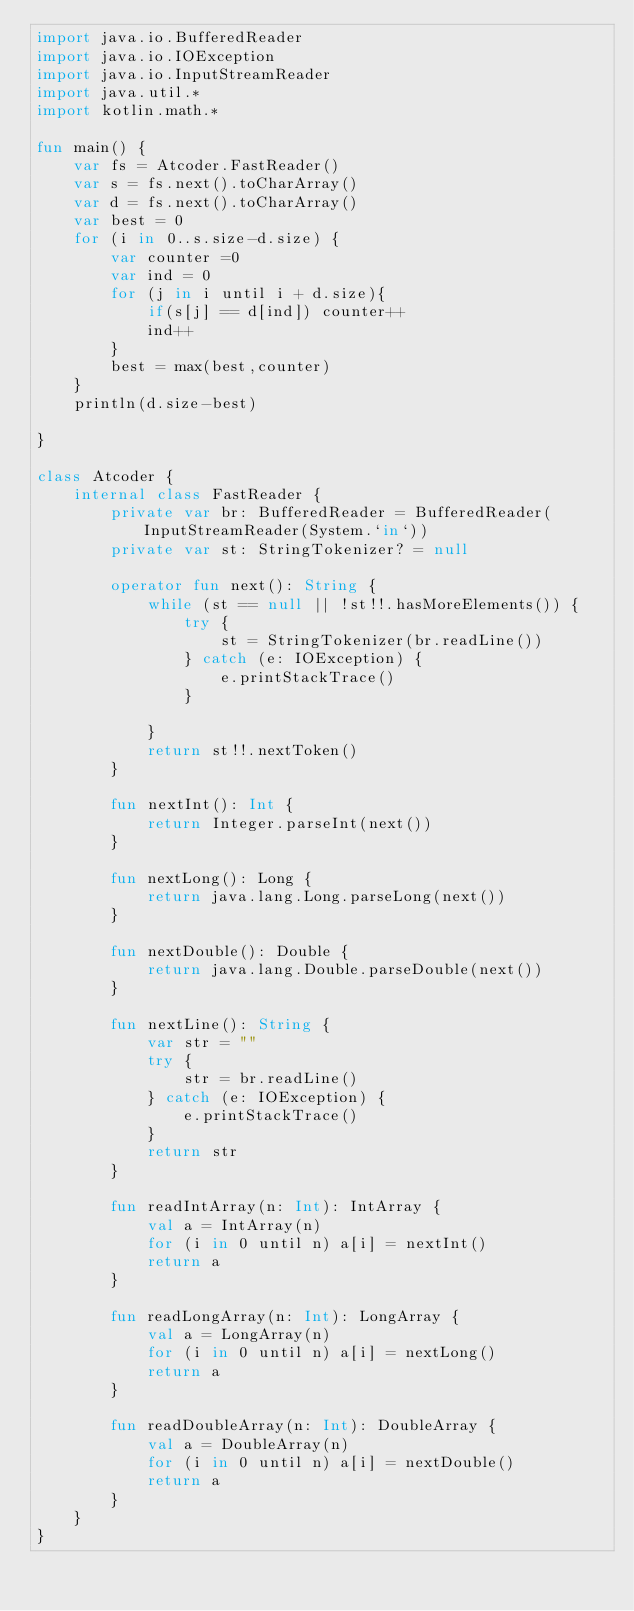<code> <loc_0><loc_0><loc_500><loc_500><_Kotlin_>import java.io.BufferedReader
import java.io.IOException
import java.io.InputStreamReader
import java.util.*
import kotlin.math.*

fun main() {
    var fs = Atcoder.FastReader()
    var s = fs.next().toCharArray()
    var d = fs.next().toCharArray()
    var best = 0
    for (i in 0..s.size-d.size) {
        var counter =0
        var ind = 0
        for (j in i until i + d.size){
            if(s[j] == d[ind]) counter++
            ind++
        }
        best = max(best,counter)
    }
    println(d.size-best)

}

class Atcoder {
    internal class FastReader {
        private var br: BufferedReader = BufferedReader(InputStreamReader(System.`in`))
        private var st: StringTokenizer? = null

        operator fun next(): String {
            while (st == null || !st!!.hasMoreElements()) {
                try {
                    st = StringTokenizer(br.readLine())
                } catch (e: IOException) {
                    e.printStackTrace()
                }

            }
            return st!!.nextToken()
        }

        fun nextInt(): Int {
            return Integer.parseInt(next())
        }

        fun nextLong(): Long {
            return java.lang.Long.parseLong(next())
        }

        fun nextDouble(): Double {
            return java.lang.Double.parseDouble(next())
        }

        fun nextLine(): String {
            var str = ""
            try {
                str = br.readLine()
            } catch (e: IOException) {
                e.printStackTrace()
            }
            return str
        }

        fun readIntArray(n: Int): IntArray {
            val a = IntArray(n)
            for (i in 0 until n) a[i] = nextInt()
            return a
        }

        fun readLongArray(n: Int): LongArray {
            val a = LongArray(n)
            for (i in 0 until n) a[i] = nextLong()
            return a
        }

        fun readDoubleArray(n: Int): DoubleArray {
            val a = DoubleArray(n)
            for (i in 0 until n) a[i] = nextDouble()
            return a
        }
    }
}
</code> 